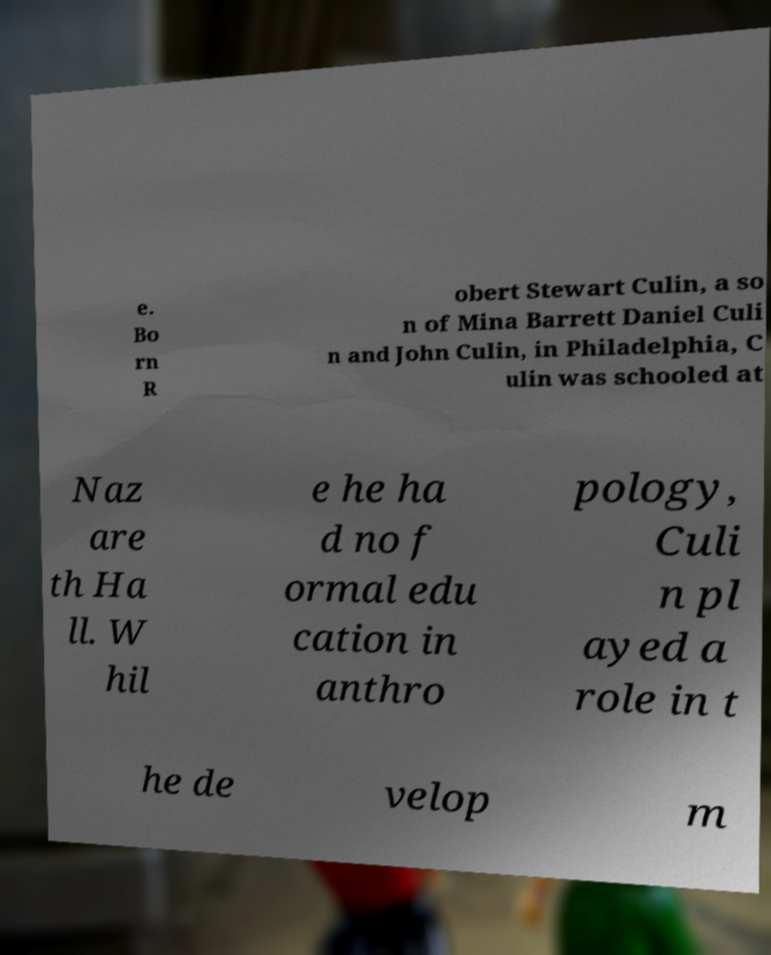For documentation purposes, I need the text within this image transcribed. Could you provide that? e. Bo rn R obert Stewart Culin, a so n of Mina Barrett Daniel Culi n and John Culin, in Philadelphia, C ulin was schooled at Naz are th Ha ll. W hil e he ha d no f ormal edu cation in anthro pology, Culi n pl ayed a role in t he de velop m 